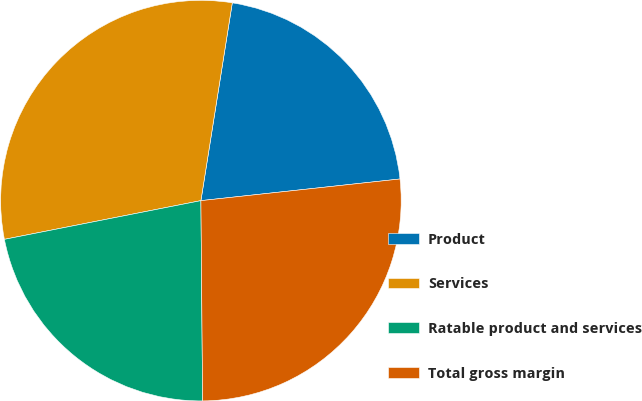Convert chart to OTSL. <chart><loc_0><loc_0><loc_500><loc_500><pie_chart><fcel>Product<fcel>Services<fcel>Ratable product and services<fcel>Total gross margin<nl><fcel>20.77%<fcel>30.6%<fcel>22.04%<fcel>26.59%<nl></chart> 